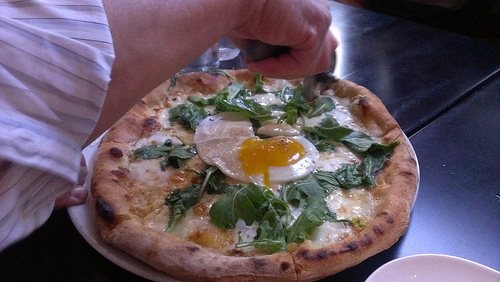Which kind of vegetable is to the left of the cheese? The vegetable to the left of the cheese is spinach. 